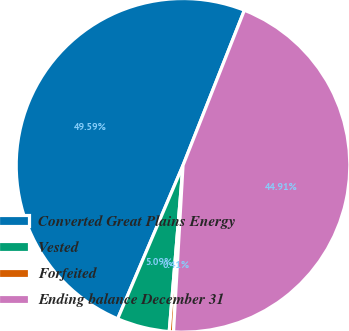<chart> <loc_0><loc_0><loc_500><loc_500><pie_chart><fcel>Converted Great Plains Energy<fcel>Vested<fcel>Forfeited<fcel>Ending balance December 31<nl><fcel>49.59%<fcel>5.09%<fcel>0.41%<fcel>44.91%<nl></chart> 